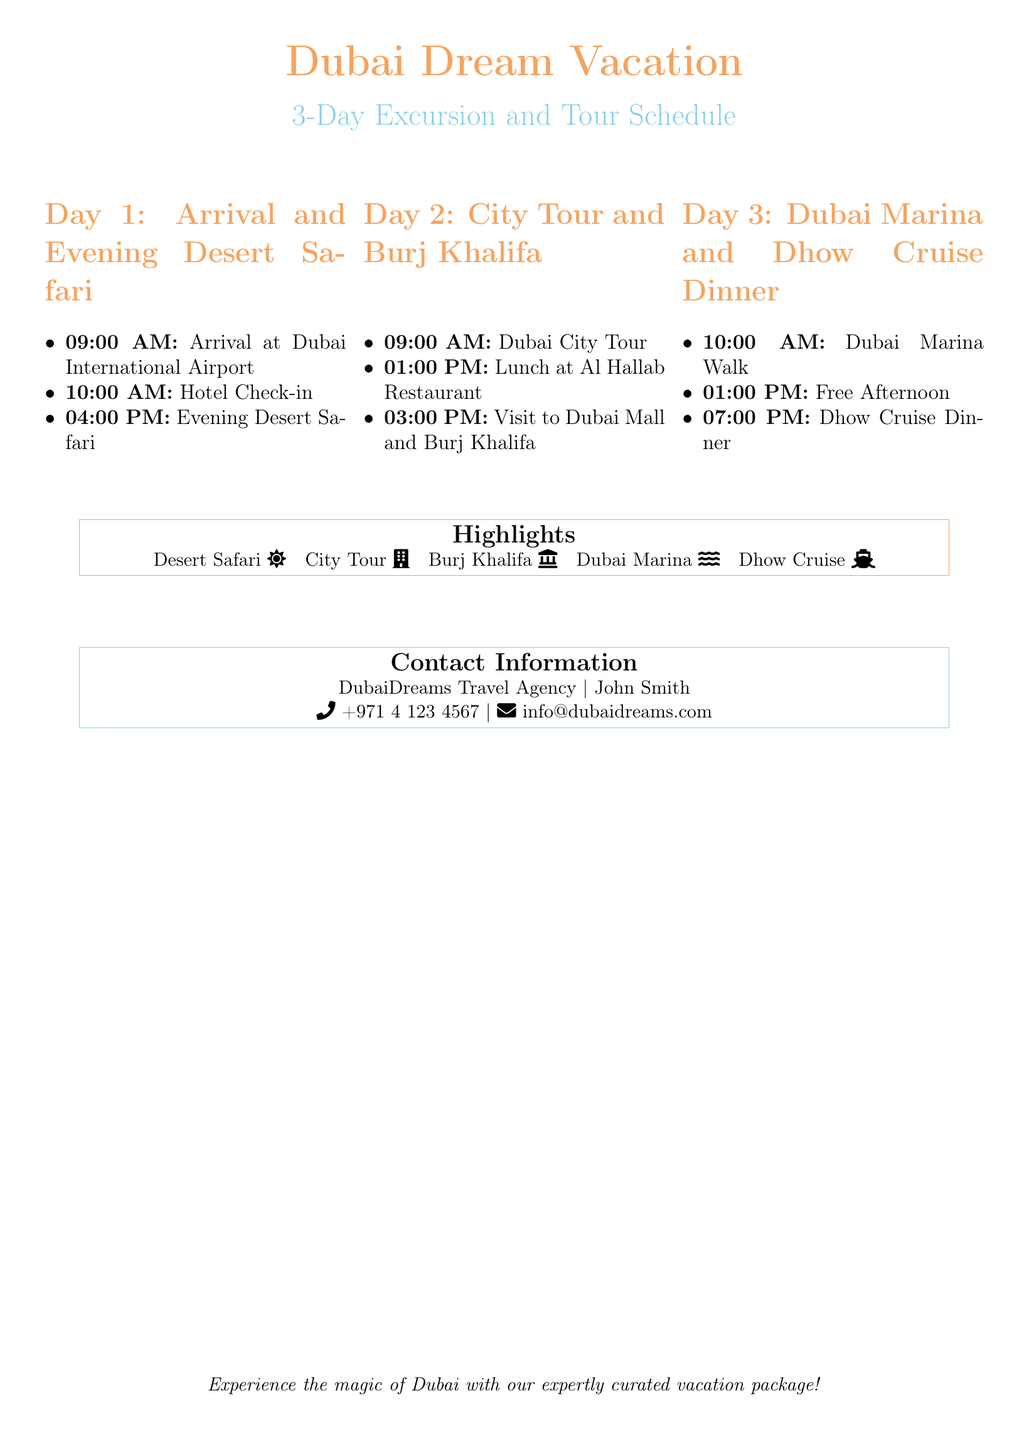What time is the airport arrival? The document specifies the arrival time at Dubai International Airport as 09:00 AM.
Answer: 09:00 AM What activity is scheduled at 04:00 PM on Day 1? The activity scheduled at 04:00 PM on Day 1 is the Evening Desert Safari.
Answer: Evening Desert Safari What is included in Day 2's itinerary for lunch? The document states that lunch on Day 2 is at Al Hallab Restaurant.
Answer: Al Hallab Restaurant How long is the free afternoon on Day 3? The document does not specify the duration of the free afternoon, only mentioning it starts at 01:00 PM.
Answer: Free Afternoon What attraction is visited after lunch on Day 2? The attraction visited after lunch on Day 2 is the Dubai Mall and Burj Khalifa.
Answer: Dubai Mall and Burj Khalifa What is the highlight activity that involves water? The document highlights the Dhow Cruise as the activity involving water.
Answer: Dhow Cruise What time does the Dhow Cruise Dinner start? The document states that the Dhow Cruise Dinner starts at 07:00 PM.
Answer: 07:00 PM Who is the contact person for the travel agency? The contact person for the travel agency is John Smith.
Answer: John Smith 